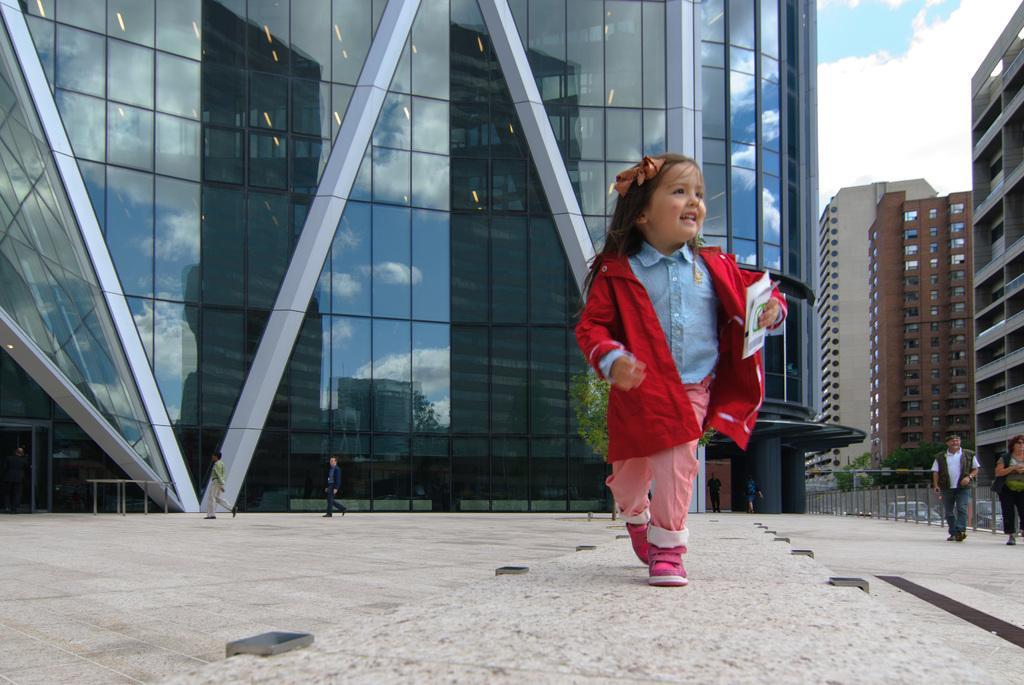In one or two sentences, can you explain what this image depicts? In this image, there are a few people, buildings, vehicles, trees. We can see the ground and the sky with clouds. We can also see the fence. 